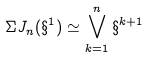<formula> <loc_0><loc_0><loc_500><loc_500>\Sigma J _ { n } ( \S ^ { 1 } ) \simeq \bigvee _ { k = 1 } ^ { n } \S ^ { k + 1 }</formula> 